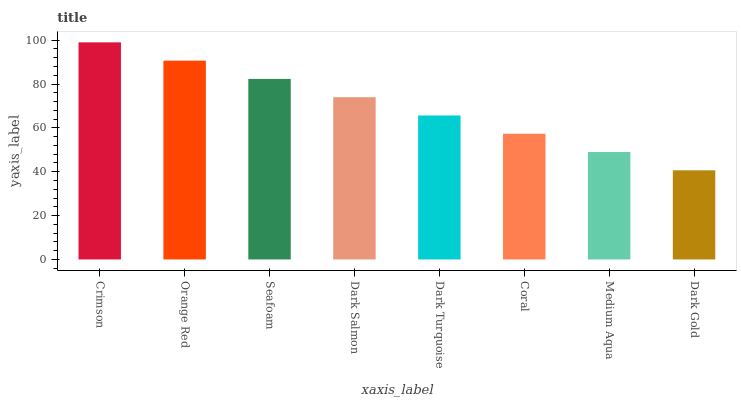Is Dark Gold the minimum?
Answer yes or no. Yes. Is Crimson the maximum?
Answer yes or no. Yes. Is Orange Red the minimum?
Answer yes or no. No. Is Orange Red the maximum?
Answer yes or no. No. Is Crimson greater than Orange Red?
Answer yes or no. Yes. Is Orange Red less than Crimson?
Answer yes or no. Yes. Is Orange Red greater than Crimson?
Answer yes or no. No. Is Crimson less than Orange Red?
Answer yes or no. No. Is Dark Salmon the high median?
Answer yes or no. Yes. Is Dark Turquoise the low median?
Answer yes or no. Yes. Is Dark Turquoise the high median?
Answer yes or no. No. Is Coral the low median?
Answer yes or no. No. 